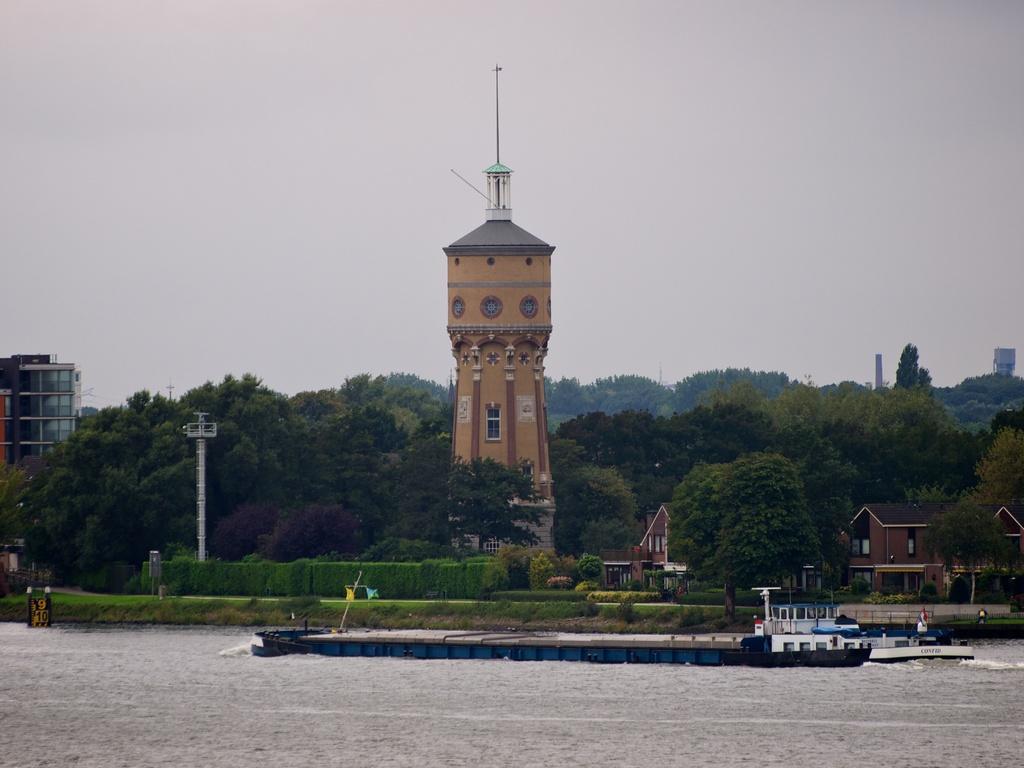Could you give a brief overview of what you see in this image? In this image in the center there is water, on the water there is ship sailing on the water and in the background there are plants, trees, and there are towers and there is a building on the left side and the sky is cloudy and there are huts. 